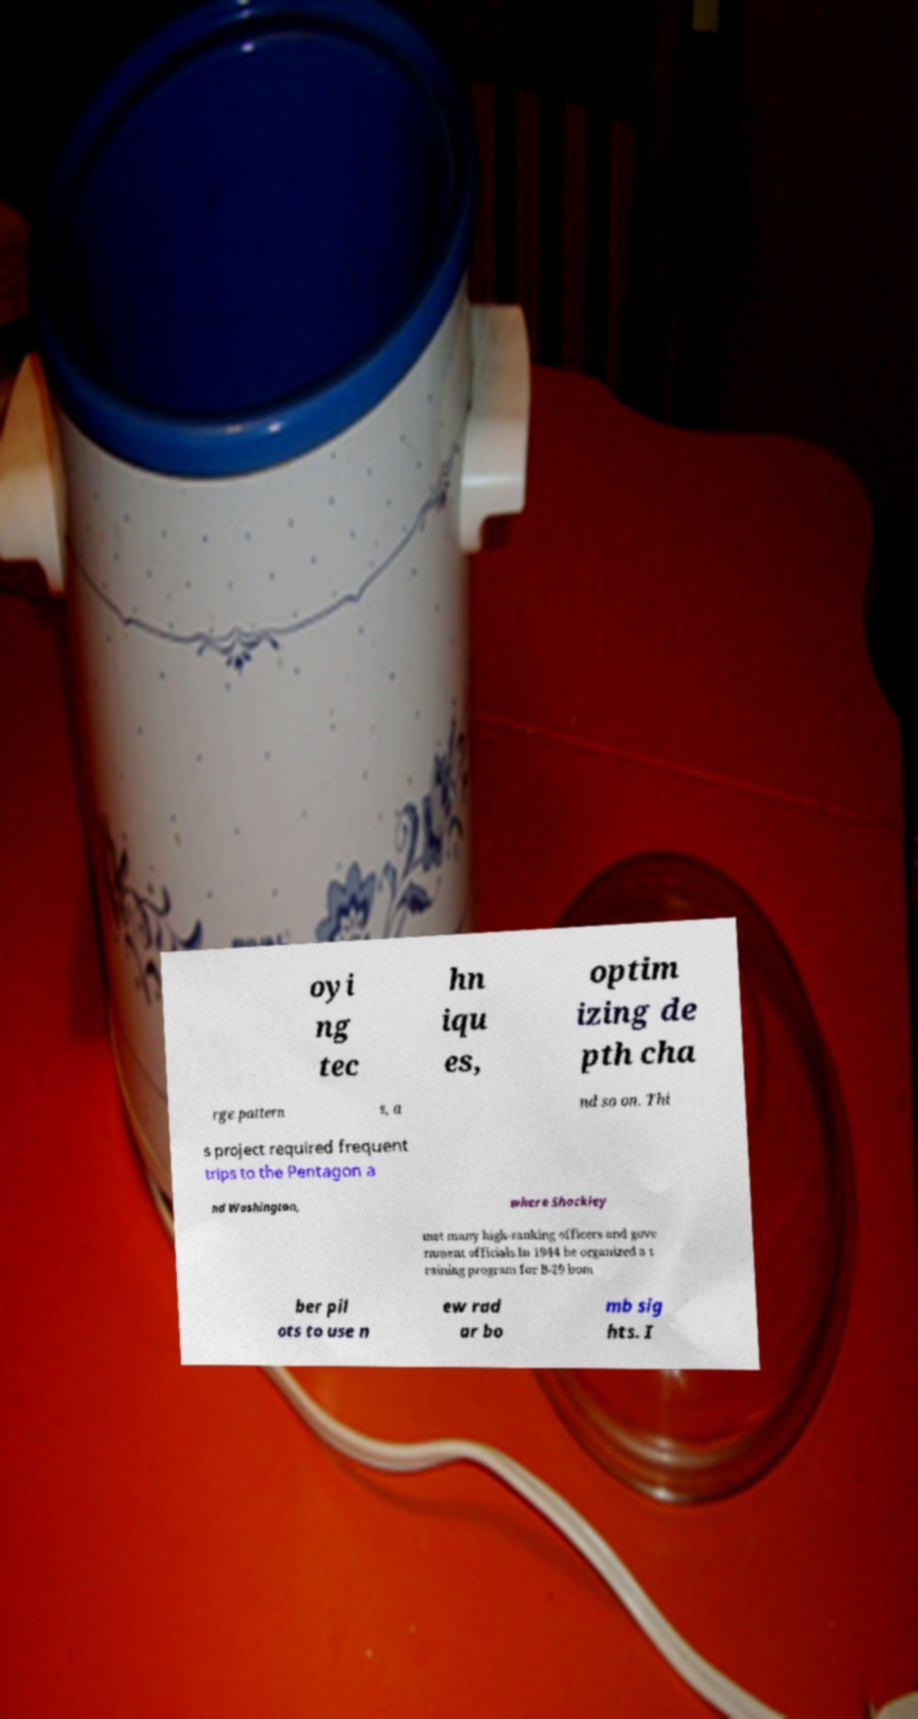Can you accurately transcribe the text from the provided image for me? oyi ng tec hn iqu es, optim izing de pth cha rge pattern s, a nd so on. Thi s project required frequent trips to the Pentagon a nd Washington, where Shockley met many high-ranking officers and gove rnment officials.In 1944 he organized a t raining program for B-29 bom ber pil ots to use n ew rad ar bo mb sig hts. I 